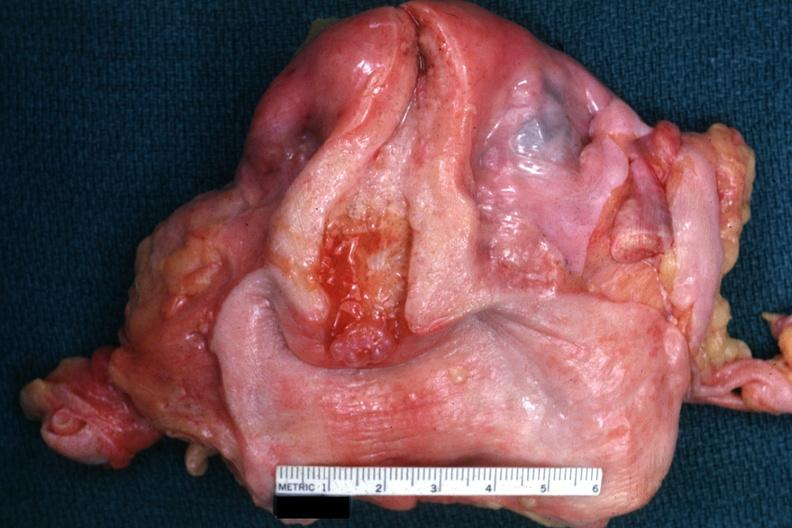s female reproductive present?
Answer the question using a single word or phrase. Yes 